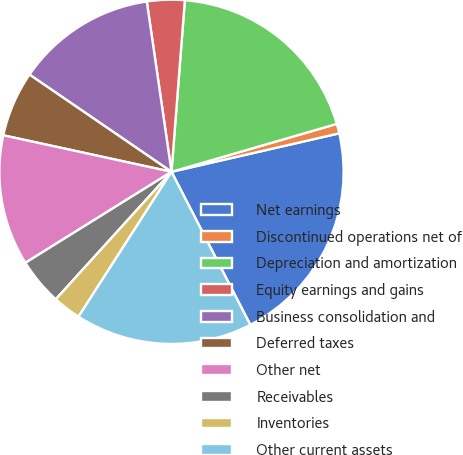Convert chart to OTSL. <chart><loc_0><loc_0><loc_500><loc_500><pie_chart><fcel>Net earnings<fcel>Discontinued operations net of<fcel>Depreciation and amortization<fcel>Equity earnings and gains<fcel>Business consolidation and<fcel>Deferred taxes<fcel>Other net<fcel>Receivables<fcel>Inventories<fcel>Other current assets<nl><fcel>21.02%<fcel>0.9%<fcel>19.27%<fcel>3.53%<fcel>13.15%<fcel>6.15%<fcel>12.27%<fcel>4.4%<fcel>2.65%<fcel>16.65%<nl></chart> 